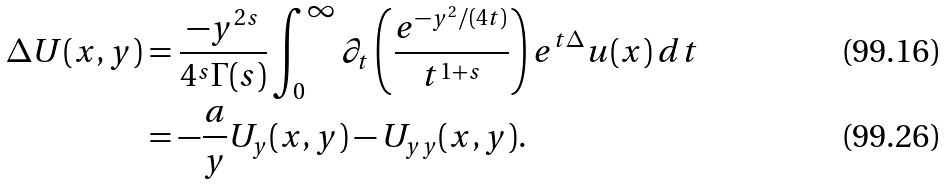<formula> <loc_0><loc_0><loc_500><loc_500>\Delta U ( x , y ) & = \frac { - y ^ { 2 s } } { 4 ^ { s } \Gamma ( s ) } \int _ { 0 } ^ { \infty } \partial _ { t } \left ( \frac { e ^ { - y ^ { 2 } / ( 4 t ) } } { t ^ { 1 + s } } \right ) e ^ { t \Delta } u ( x ) \, d t \\ & = - \frac { a } { y } U _ { y } ( x , y ) - U _ { y y } ( x , y ) .</formula> 